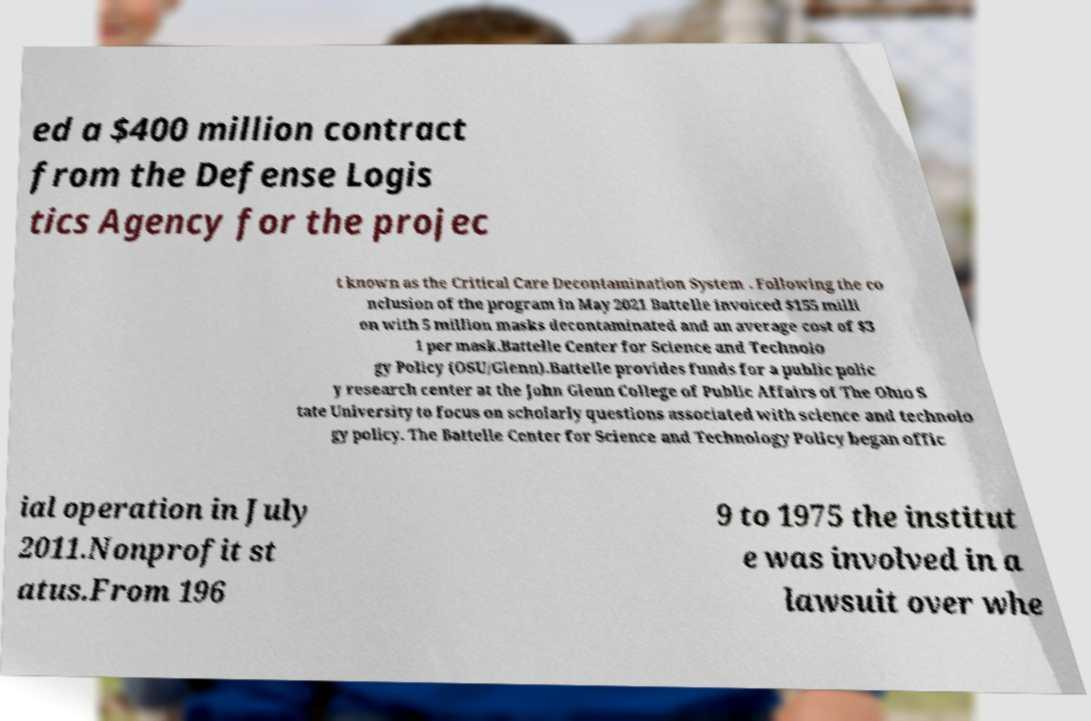I need the written content from this picture converted into text. Can you do that? ed a $400 million contract from the Defense Logis tics Agency for the projec t known as the Critical Care Decontamination System . Following the co nclusion of the program in May 2021 Battelle invoiced $155 milli on with 5 million masks decontaminated and an average cost of $3 1 per mask.Battelle Center for Science and Technolo gy Policy (OSU/Glenn).Battelle provides funds for a public polic y research center at the John Glenn College of Public Affairs of The Ohio S tate University to focus on scholarly questions associated with science and technolo gy policy. The Battelle Center for Science and Technology Policy began offic ial operation in July 2011.Nonprofit st atus.From 196 9 to 1975 the institut e was involved in a lawsuit over whe 